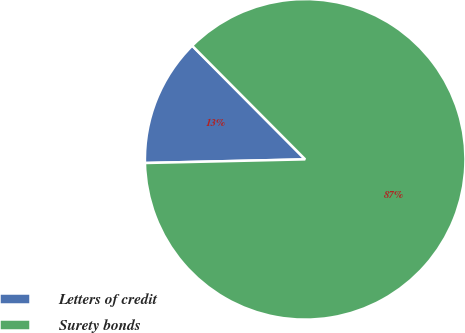Convert chart to OTSL. <chart><loc_0><loc_0><loc_500><loc_500><pie_chart><fcel>Letters of credit<fcel>Surety bonds<nl><fcel>12.91%<fcel>87.09%<nl></chart> 